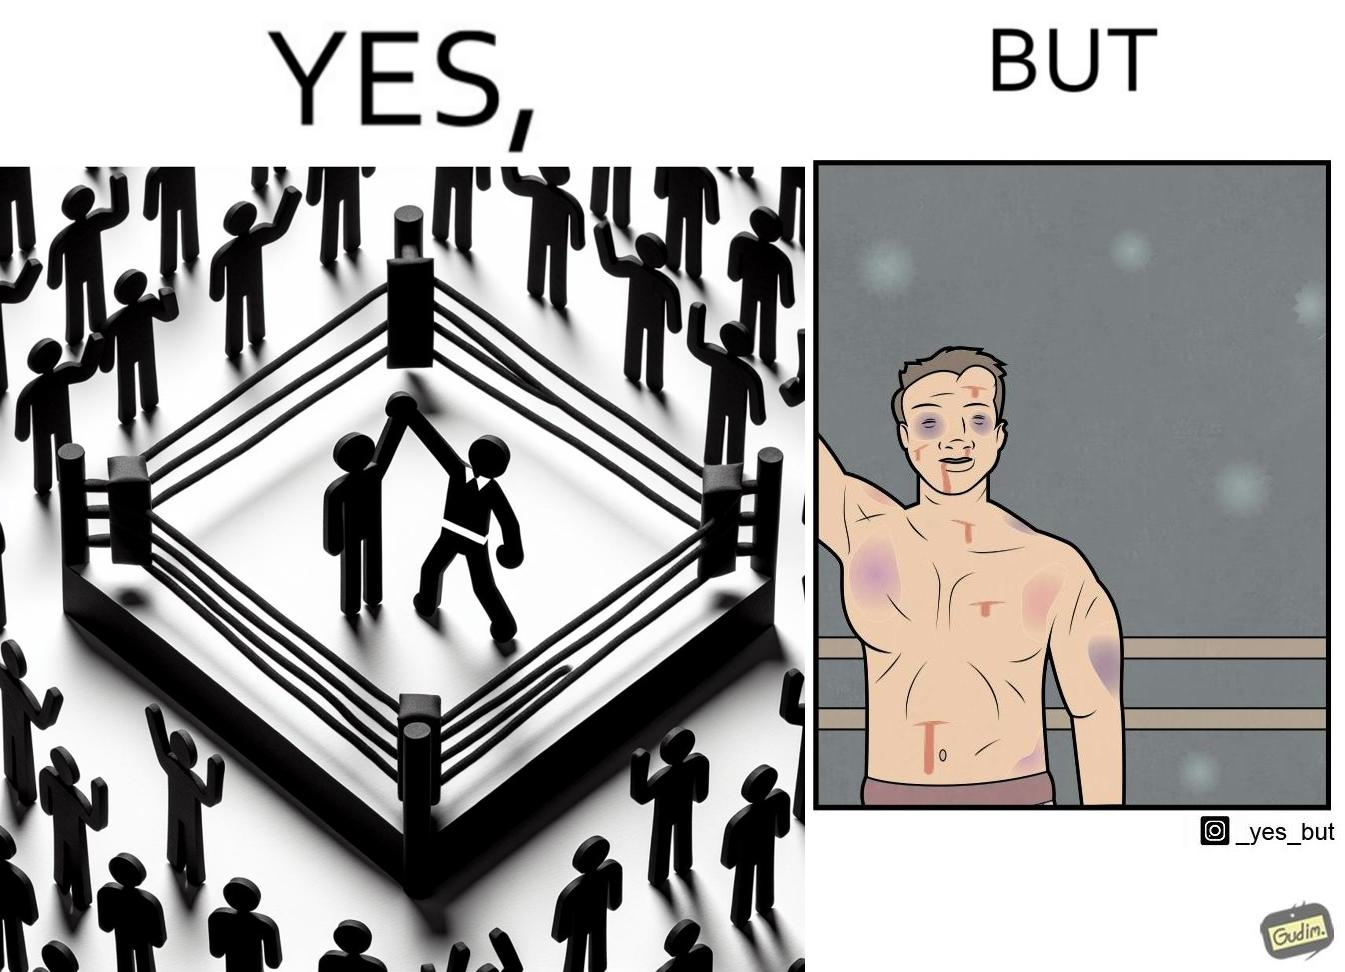Is this a satirical image? Yes, this image is satirical. 